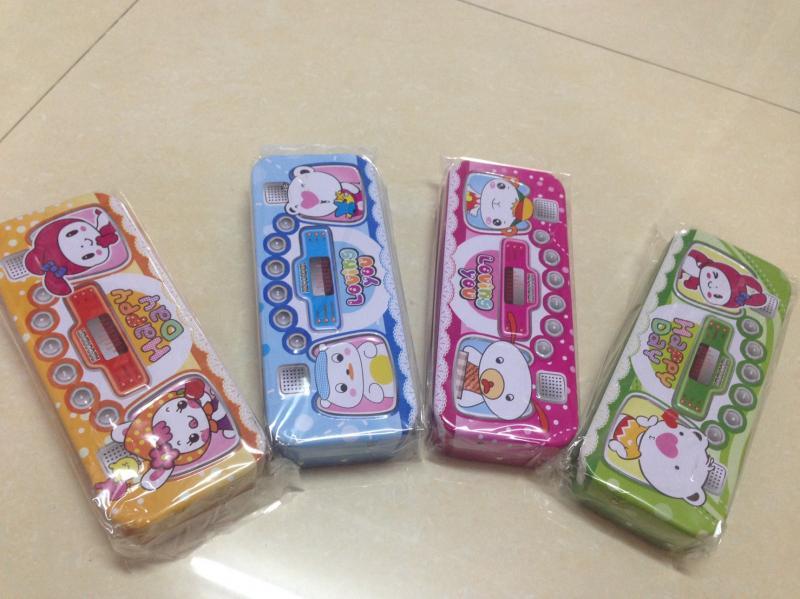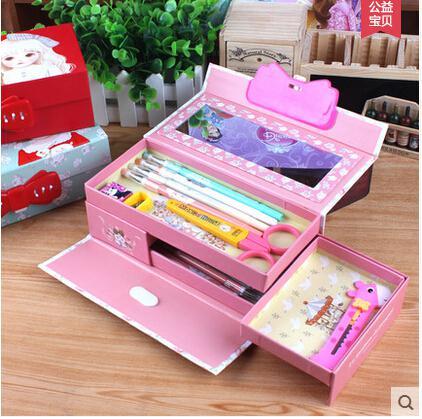The first image is the image on the left, the second image is the image on the right. Evaluate the accuracy of this statement regarding the images: "One image shows a filled box-shaped pink pencil case with a flip-up lid, and the other image shows several versions of closed cases with cartoon creatures on the fronts.". Is it true? Answer yes or no. Yes. The first image is the image on the left, the second image is the image on the right. Assess this claim about the two images: "One of the images has a container of flowers in the background.". Correct or not? Answer yes or no. No. 